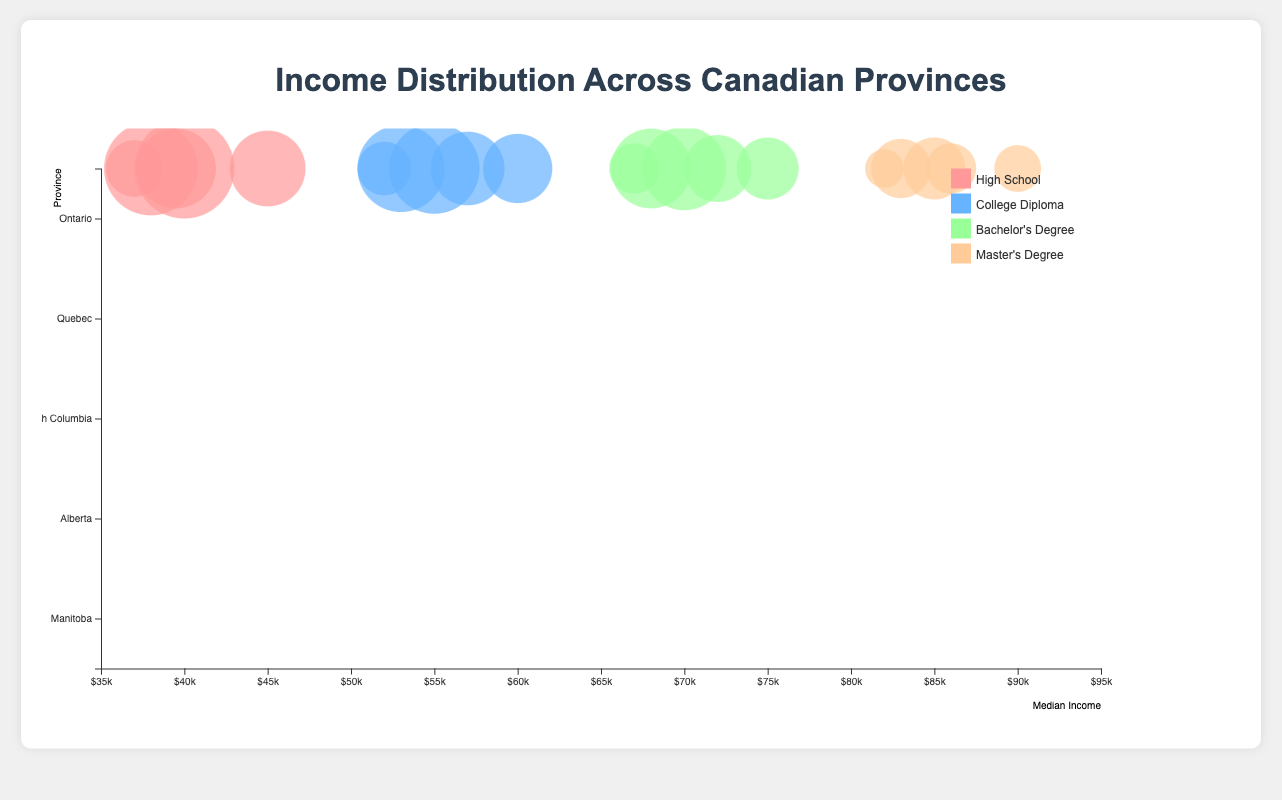What is the median income for individuals with a Bachelor's Degree in Quebec? The chart shows the median income for each education level within each province. By looking at Quebec's section and locating the Bachelor's Degree bubble, we can see the value is $68,000
Answer: $68,000 Which province has the highest median income for individuals with a High School education? By examining each province's High School education bubble, we see that Alberta has the highest median income at $45,000
Answer: Alberta How does the median income for a Master’s Degree in British Columbia compare to that in Manitoba? Locate the Master's Degree bubbles for British Columbia and Manitoba. British Columbia shows $86,000, and Manitoba shows $82,000. So, British Columbia's median income is higher
Answer: British Columbia What is the total population of individuals with a College Diploma in Ontario? The bubble chart's size indicates the population. For Ontario's College Diploma, the population is 1,200,000.
Answer: 1,200,000 Which province has the smallest population for individuals with a Master's Degree, and what is the population? By comparing bubble sizes for Master's Degrees across provinces, Manitoba has the smallest population with 150,000
Answer: Manitoba, 150,000 What is the difference in median income between a High School education and a Bachelor's Degree in Alberta? The High School median income in Alberta is $45,000, and for a Bachelor's Degree, it's $75,000. The difference is $75,000 - $45,000 = $30,000
Answer: $30,000 Across all provinces, which education level generally has the highest median income? By analyzing the bubble positions along the x-axis (income), Master's Degree bubbles are consistently the farthest to the right, indicating the highest median income
Answer: Master’s Degree How does the median income for a College Diploma in British Columbia compare to that in Quebec? The median income for a College Diploma in British Columbia is $57,000, while in Quebec, it is $53,000. Hence, British Columbia has a higher median income for this education level
Answer: British Columbia What is the average median income for individuals with a Bachelor's Degree across all listed provinces? Sum the median incomes for Bachelor's Degrees across the provinces: (70,000 + 68,000 + 72,000 + 75,000 + 67,000) = 352,000, then divide by the number of provinces, which is 5. So, 352,000 / 5 = 70,400
Answer: $70,400 